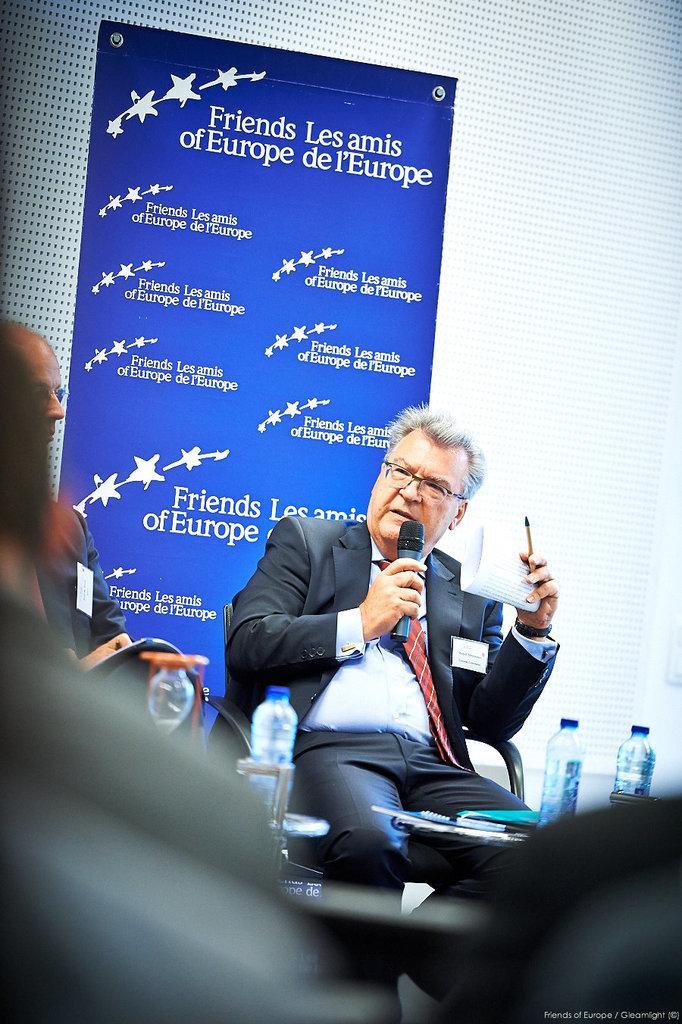In one or two sentences, can you explain what this image depicts? In this picture we can see some people are sitting on chairs. A man is holding a microphone, paper and a pen. In front of the people there are tables and on the tables there are bottles, books and an object. Behind the people, it looks like a wall and on the wall there is a banner. On the image there is a watermark. 